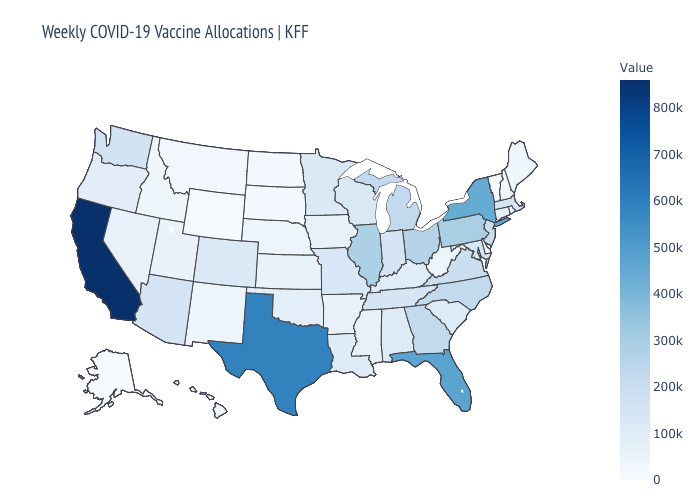Which states hav the highest value in the West?
Keep it brief. California. Does Massachusetts have the highest value in the USA?
Answer briefly. No. 